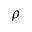<formula> <loc_0><loc_0><loc_500><loc_500>\rho</formula> 